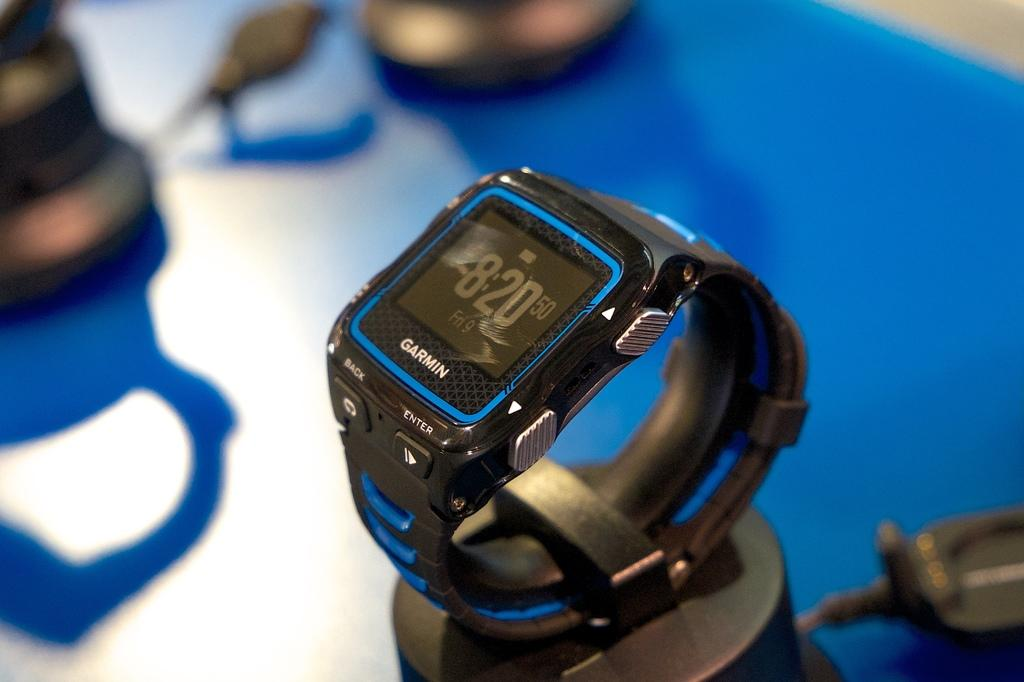<image>
Render a clear and concise summary of the photo. A Garmin watch has a time of 8:20 on the display 